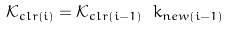Convert formula to latex. <formula><loc_0><loc_0><loc_500><loc_500>\mathcal { K } _ { c l r \left ( i \right ) } = \mathcal { K } _ { c l r \left ( i - 1 \right ) } \ k _ { n e w \left ( i - 1 \right ) }</formula> 